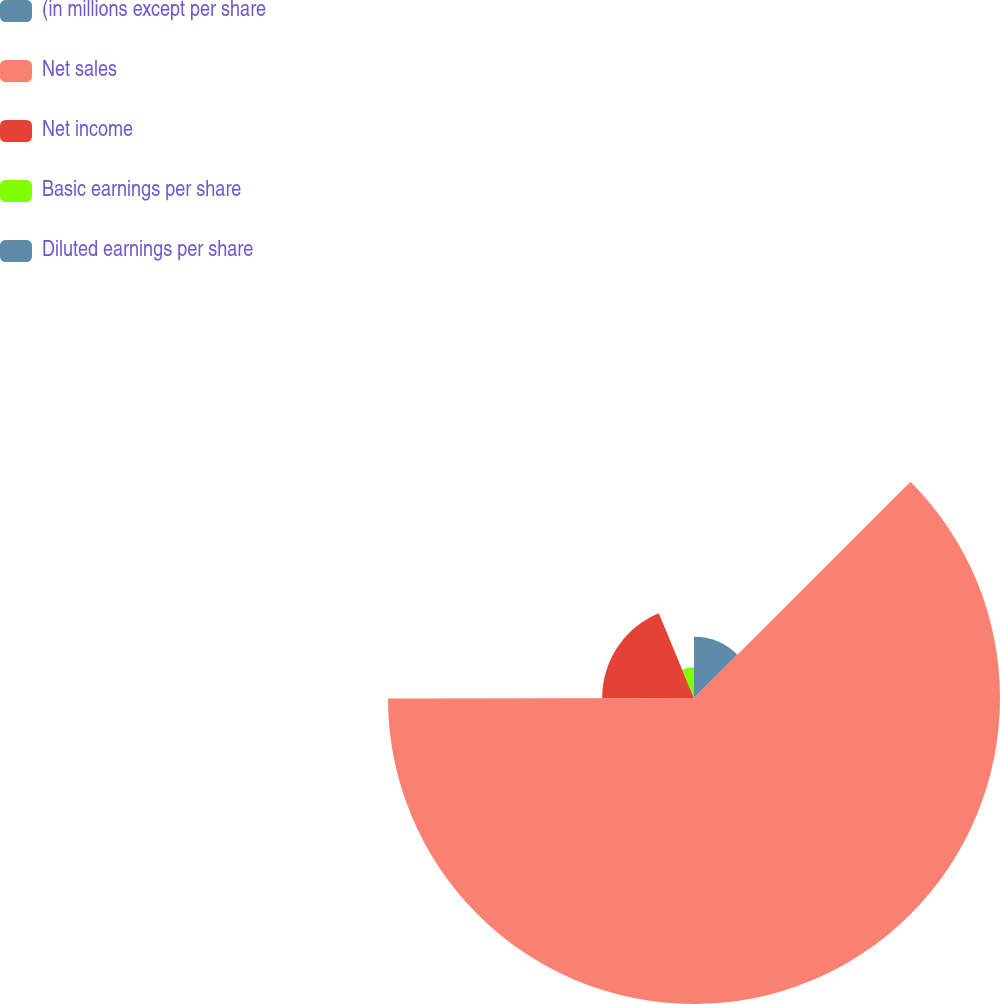Convert chart to OTSL. <chart><loc_0><loc_0><loc_500><loc_500><pie_chart><fcel>(in millions except per share<fcel>Net sales<fcel>Net income<fcel>Basic earnings per share<fcel>Diluted earnings per share<nl><fcel>12.51%<fcel>62.47%<fcel>18.75%<fcel>6.26%<fcel>0.01%<nl></chart> 